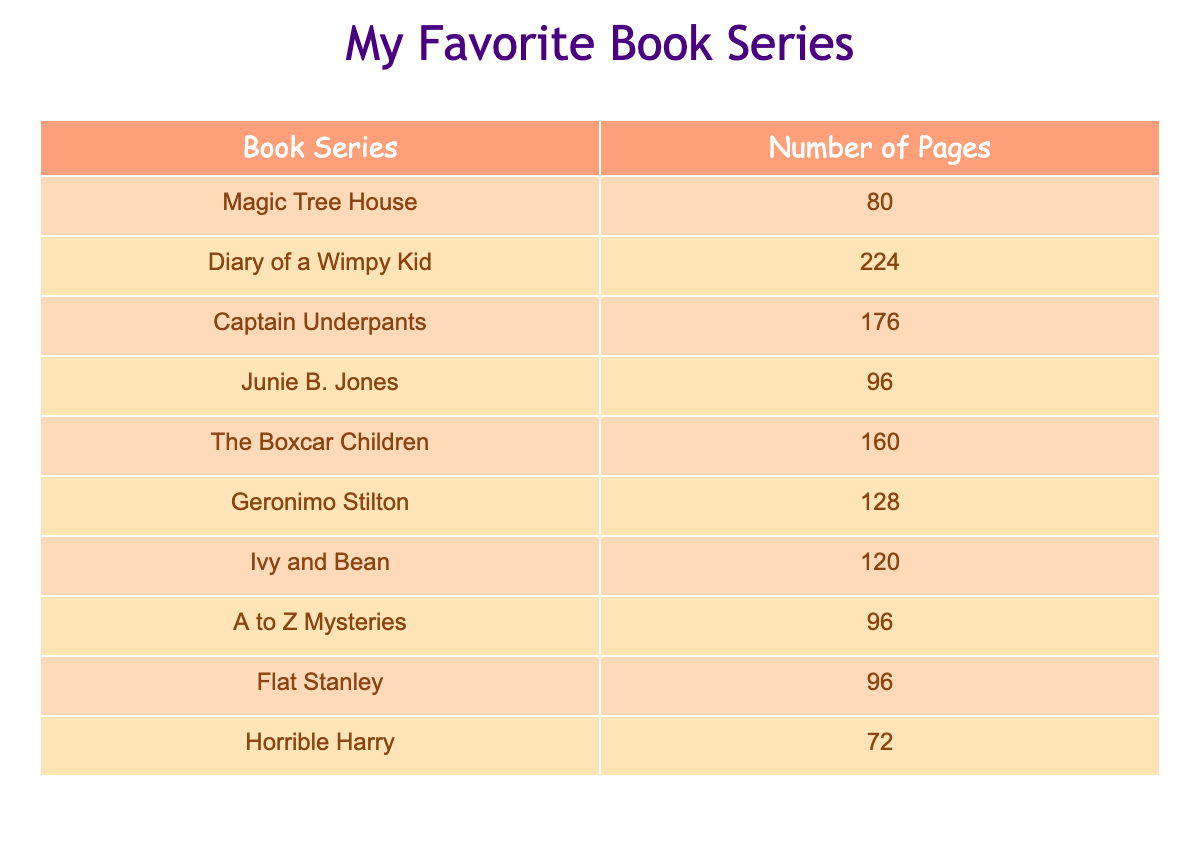What is the number of pages in the "Magic Tree House" series? The table lists the "Magic Tree House" series under the "Book Series" column. Looking at the corresponding value under the "Number of Pages" column, it shows that there are 80 pages.
Answer: 80 Which book series has the most pages? To find the book series with the most pages, we compare all the numbers in the "Number of Pages" column. The maximum number is 224, which belongs to the "Diary of a Wimpy Kid" series.
Answer: Diary of a Wimpy Kid How many pages are there in "Junie B. Jones" and "Ivy and Bean" combined? First, we find the number of pages for each series. "Junie B. Jones" has 96 pages and "Ivy and Bean" has 120 pages. Adding these two values together: 96 + 120 = 216.
Answer: 216 Is "Horrible Harry" shorter than "Magic Tree House"? The number of pages for "Horrible Harry" is 72, while "Magic Tree House" has 80 pages. Since 72 is less than 80, "Horrible Harry" is indeed shorter.
Answer: Yes What is the average number of pages among all the book series? First, we need to sum all the pages: 80 + 224 + 176 + 96 + 160 + 128 + 120 + 96 + 96 + 72 = 1,224. There are 10 book series, so we divide the total pages by 10: 1,224 / 10 = 122.4.
Answer: 122.4 